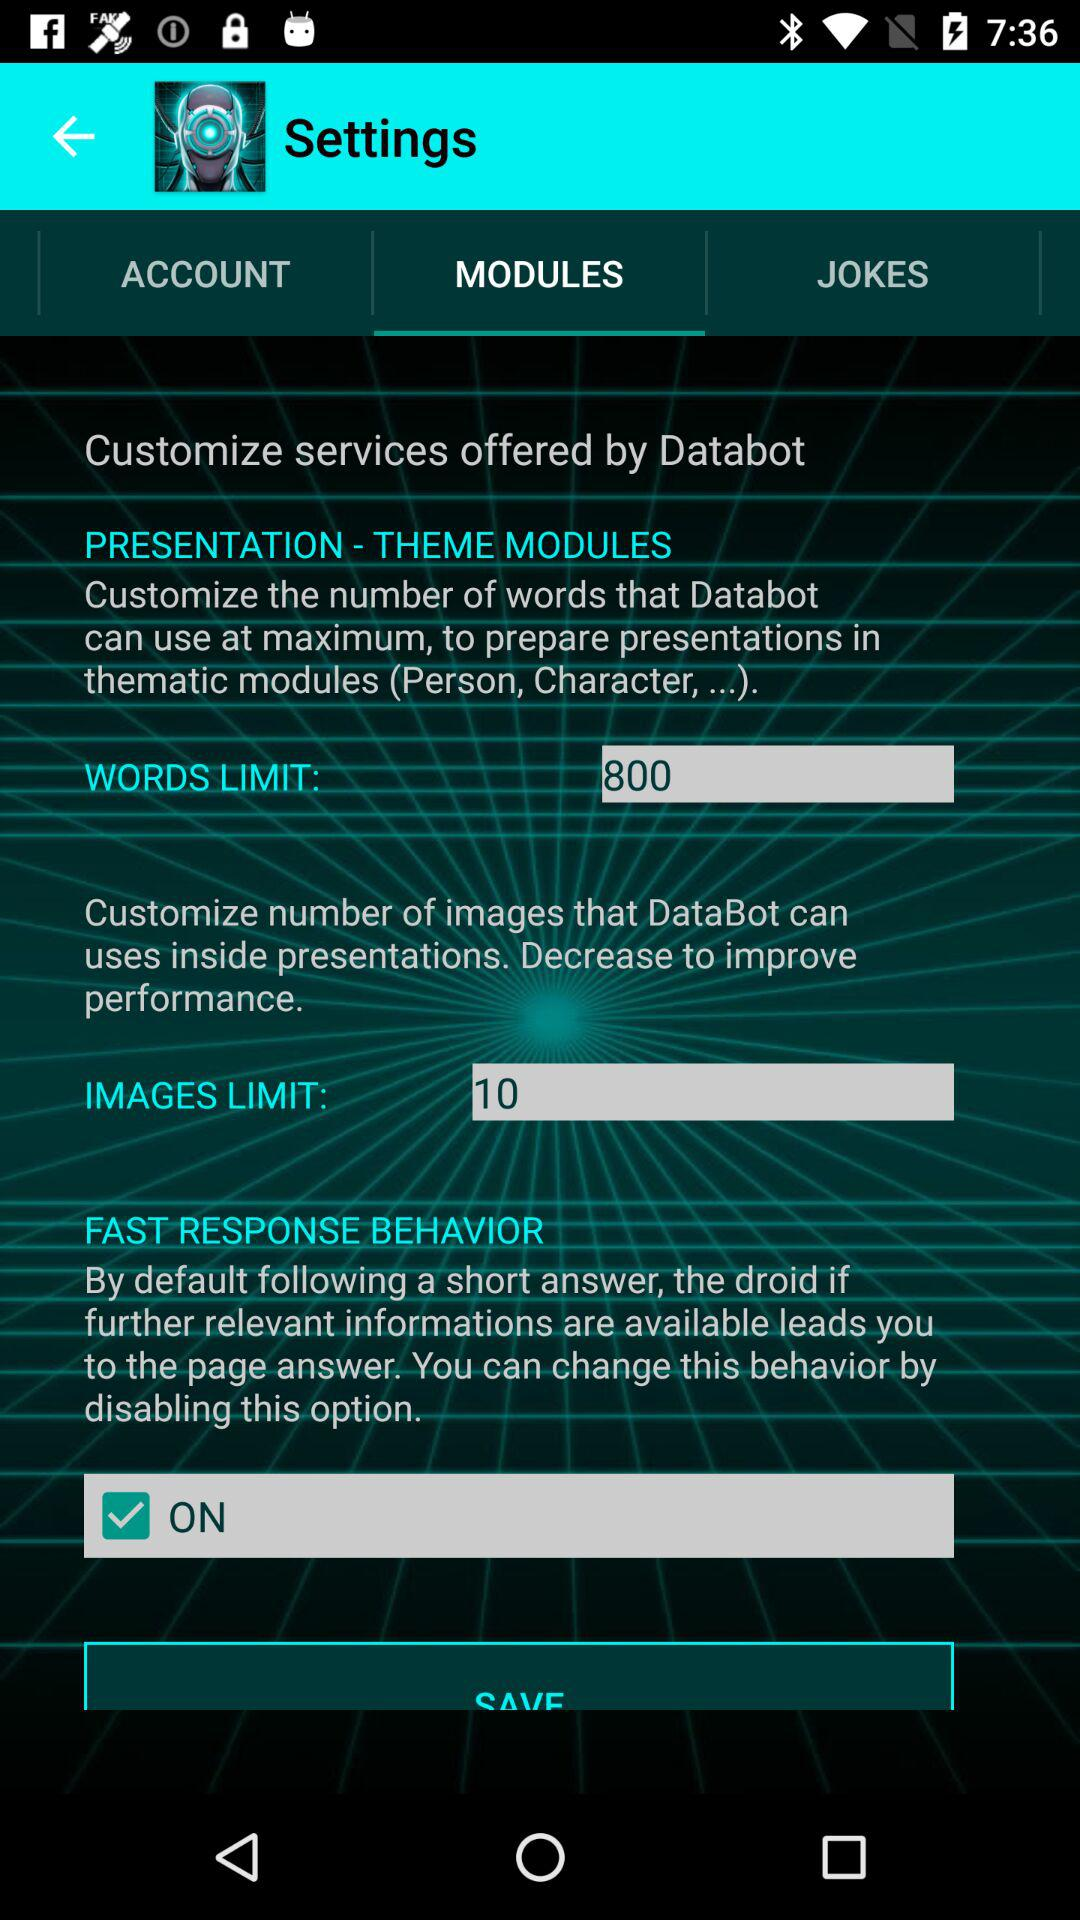What is the "WORDS LIMIT"? The "WORDS LIMIT" is 800. 